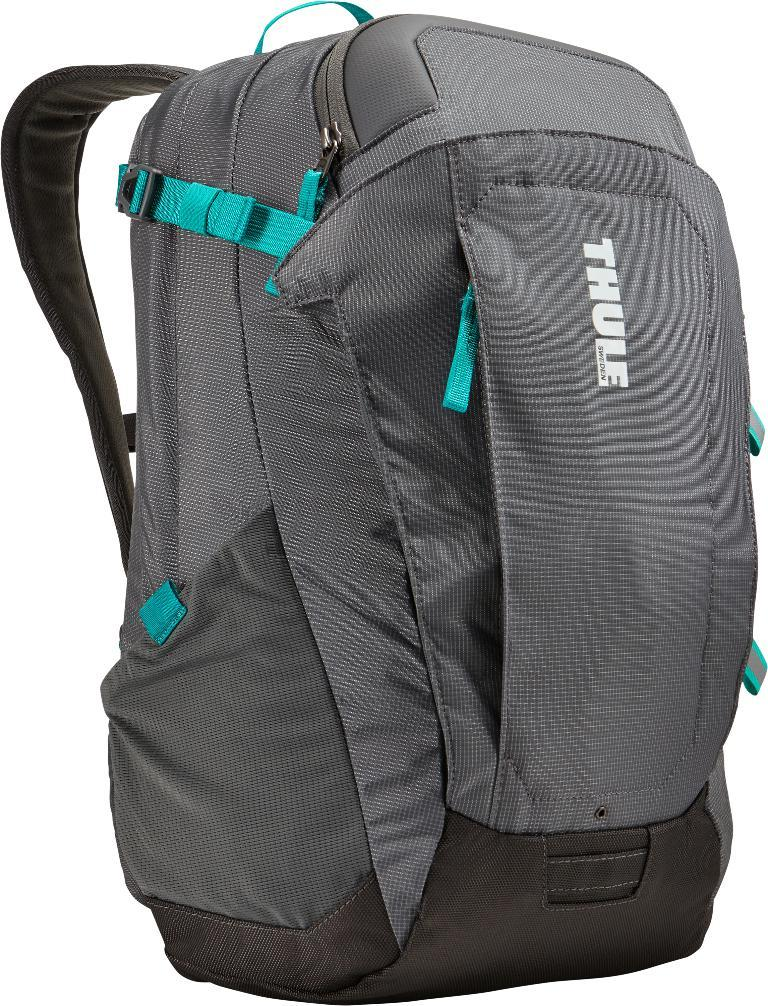What object can be seen in the picture? There is a bag in the picture. Can you see a fan in the picture? No, there is no fan present in the picture; only a bag can be seen. 